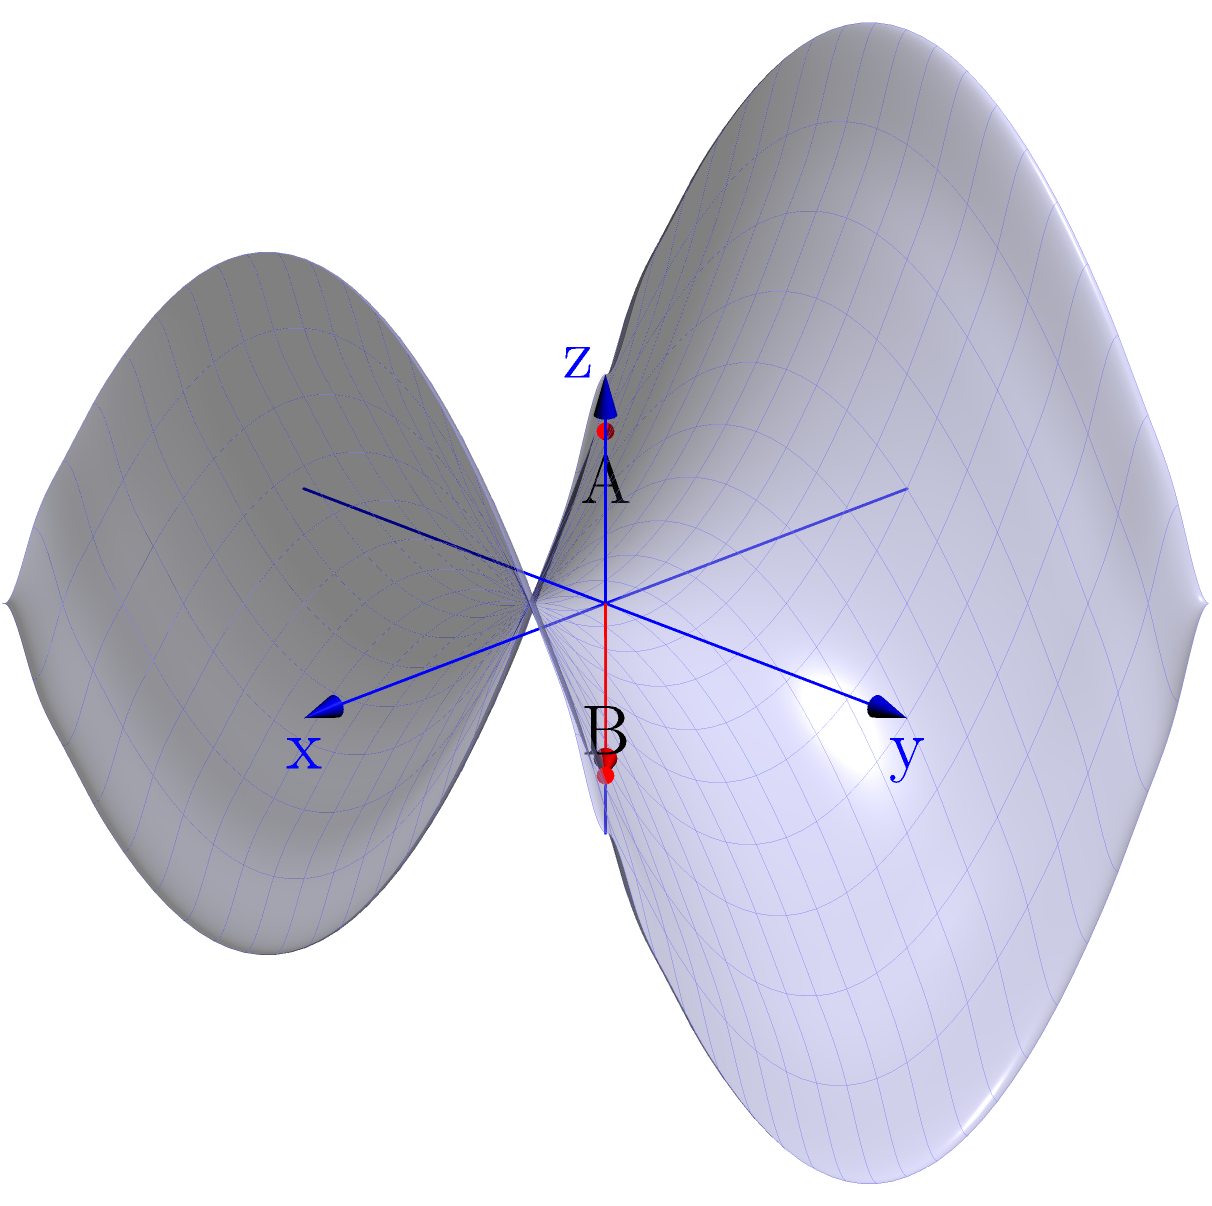As a track coach, you're designing a hill training course on a saddle-shaped terrain. Two key points, A and B, are located on opposite sides of the saddle as shown in the diagram. The surface is described by the equation $z = 0.5(x^2 - y^2)$. If a runner wants to take the shortest path between these two points, which of the following statements is true?

a) The shortest path is a straight line between A and B.
b) The shortest path follows the curve of the saddle's "valley".
c) The shortest path goes around the saddle's peak.
d) The shortest path is a geodesic curve on the surface. Let's approach this step-by-step:

1) In Euclidean geometry, the shortest path between two points is always a straight line. However, on curved surfaces (Non-Euclidean geometry), this is not necessarily true.

2) The surface given by $z = 0.5(x^2 - y^2)$ is a saddle shape, which is a hyperbolic paraboloid.

3) On curved surfaces, the shortest path between two points is called a geodesic. Geodesics have the property that they are locally straight, meaning that if you were to walk along a geodesic on the surface, it would feel like you're walking in a straight line.

4) For a saddle surface:
   - A straight line between A and B would not follow the surface contour and is thus not a valid path.
   - Following the "valley" of the saddle might seem intuitive, but it's not necessarily the shortest path.
   - Going around the peak would likely increase the distance traveled.

5) The actual shortest path on this surface would be a geodesic curve. This curve would not appear straight when viewed from above, but would minimize the distance traveled while staying on the surface.

6) In track and field terms, this is analogous to how runners might adjust their path slightly on a curved track to minimize the distance they need to run, rather than sticking strictly to their lane.

Therefore, the correct answer is that the shortest path is a geodesic curve on the surface.
Answer: d) The shortest path is a geodesic curve on the surface. 